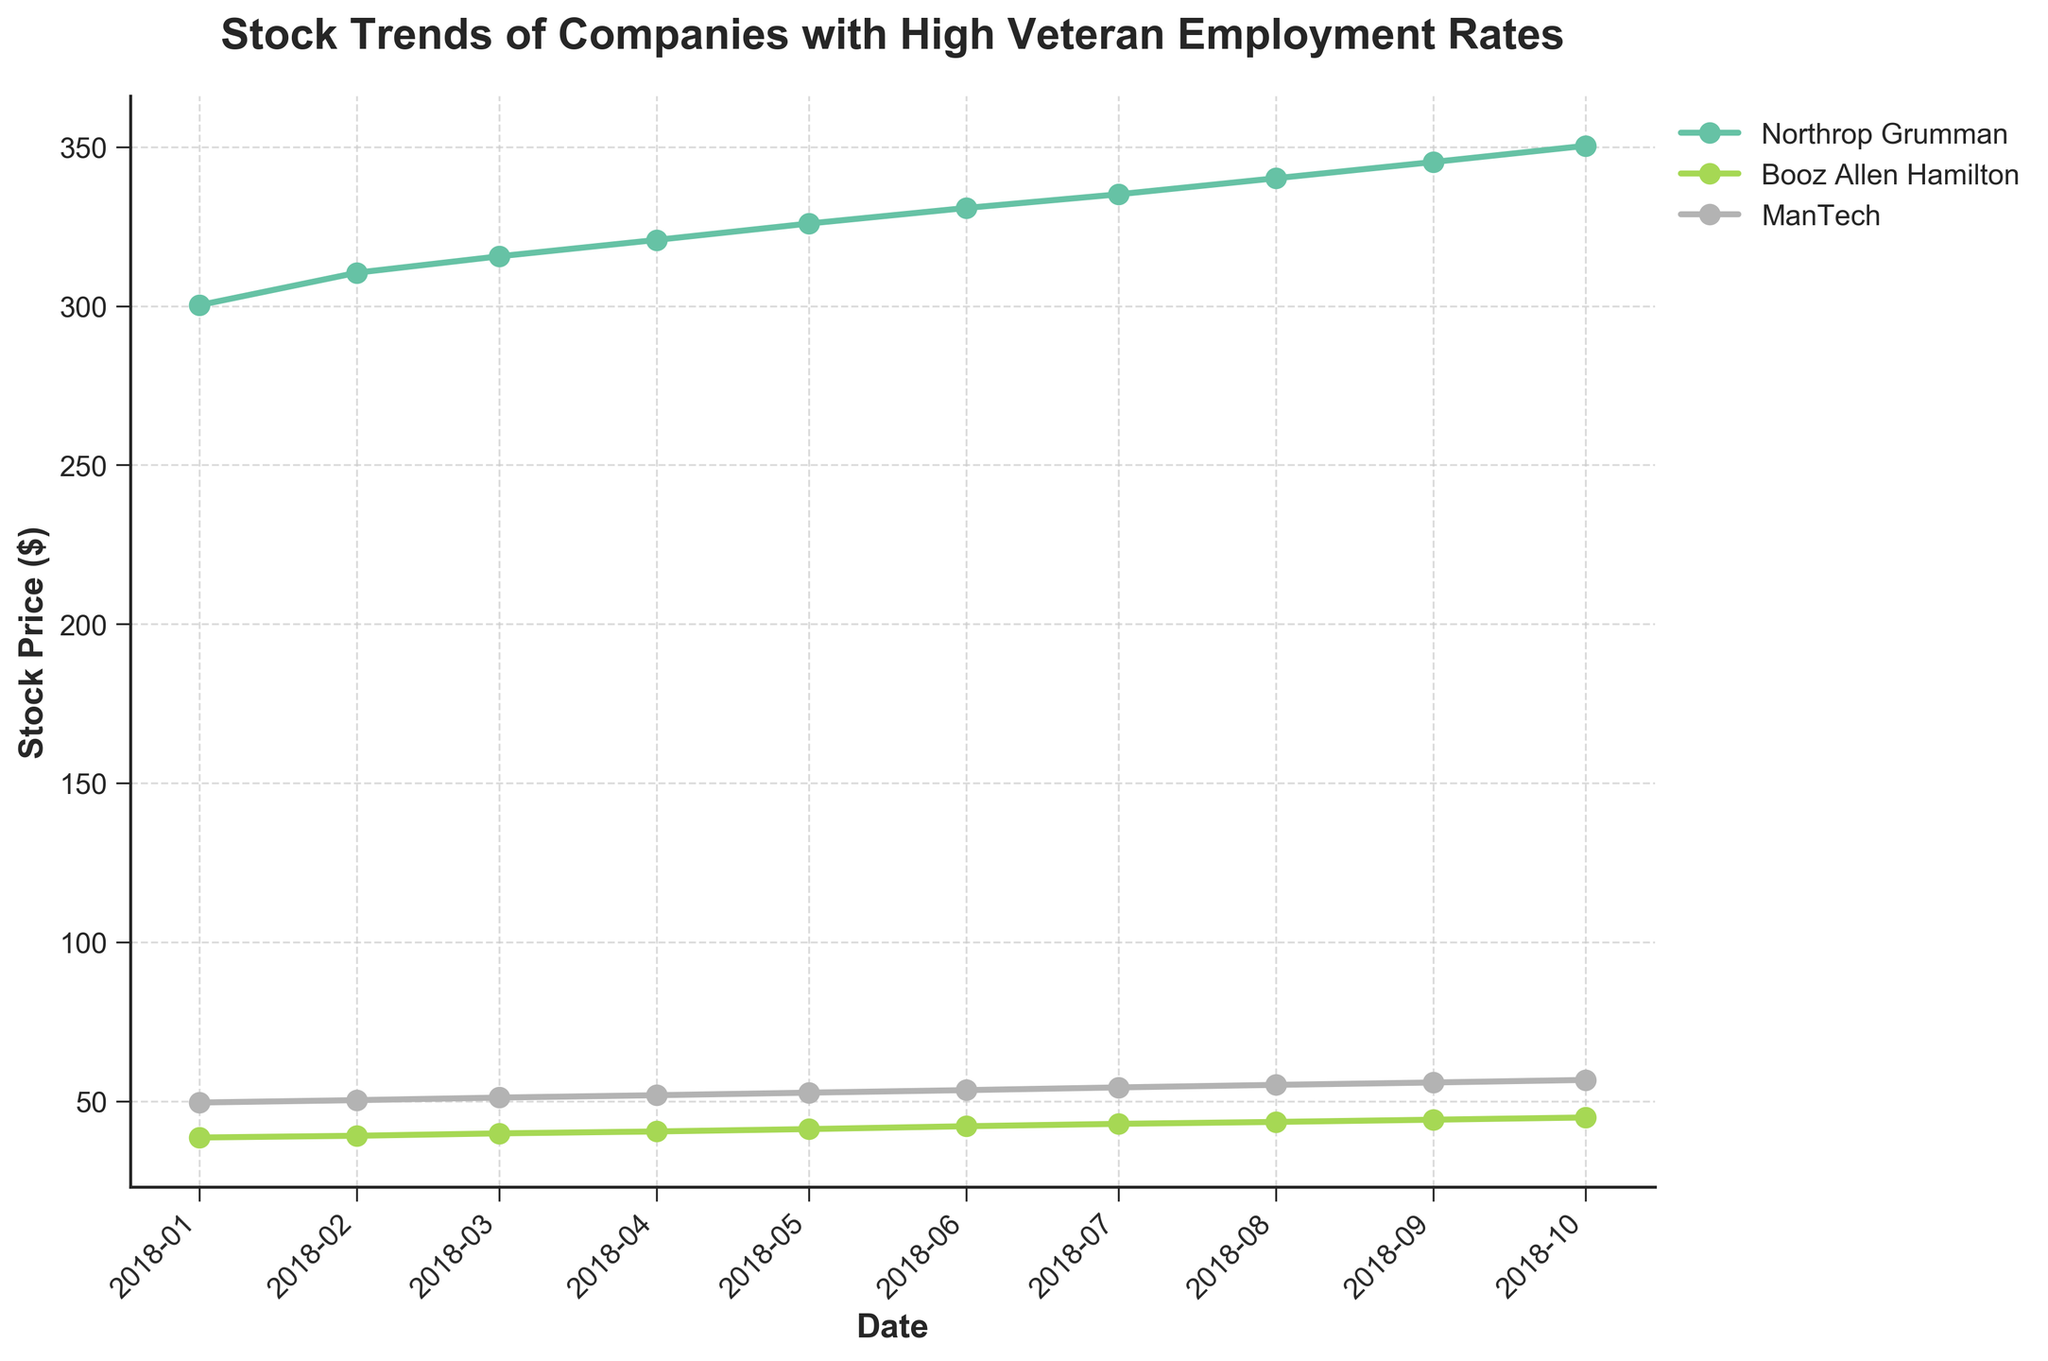What is the axis label for the x-axis? The x-axis in the figure is labeled. By inspecting the visual appearance of the axis label, you can see that it states 'Date'.
Answer: Date How many companies are represented in the figure? The figure uses different colors to represent the stock prices of each company. There are three distinct lines visible, indicating there are three companies.
Answer: 3 Which company had the highest stock price in January 2018? By locating the data points corresponding to January 2018 on the x-axis and comparing the heights of the markers for different companies, Northrop Grumman had the highest stock price.
Answer: Northrop Grumman Is the overall trend for ManTech's stock prices going up, down, or stable? By observing the general direction of the line representing ManTech's stock prices from January to October 2018, the trend is consistently upwards.
Answer: Up Which company experienced the largest increase in stock price from January 2018 to October 2018? To determine this, observe the difference in stock prices plotted for January and October 2018 for each company. Northrop Grumman shows the highest increase as it starts around $300 and ends near $350, a difference of approximately $50.
Answer: Northrop Grumman What's the difference in stock price between Booz Allen Hamilton and ManTech in April 2018? Locate the April 2018 data points for Booz Allen Hamilton and ManTech. Booz Allen Hamilton's price is around $40.45, and ManTech's price is around $51.85. The difference is 51.85 - 40.45.
Answer: 11.40 What are the markers used in the plot to represent data points? By examining the visual characteristics of the data points in the figure, such as shape and size, it's evident that markers are 'o' (circles).
Answer: Circle Between February and March 2018, which company had the smallest increase in stock price? Compare the distance between the markers along the y-axis for each company between February and March 2018. Booz Allen Hamilton had the smallest increase from approximately $39.10 to $39.85, which is a difference of 0.75.
Answer: Booz Allen Hamilton Which company has the highest stock price volatility from January to October 2018? To assess volatility, observe the changes in stock prices for each company over time and the distances between the data points across months. Northrop Grumman shows significant changes from around $300 to $350, indicating higher volatility.
Answer: Northrop Grumman What visual elements are missing on the top and right sides of the figure that might usually be present? By examining the figure, you can notice that the top and right edges do not have the usual spines or borders, which are often present in plots.
Answer: Spines 